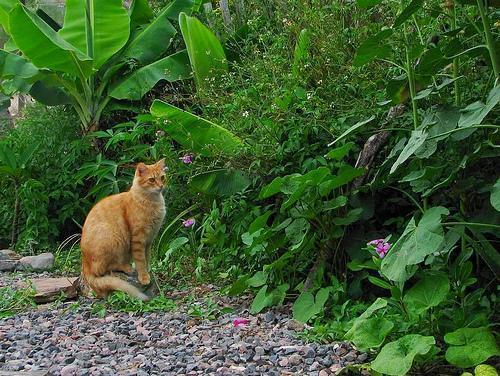How many cats are there?
Give a very brief answer. 1. 